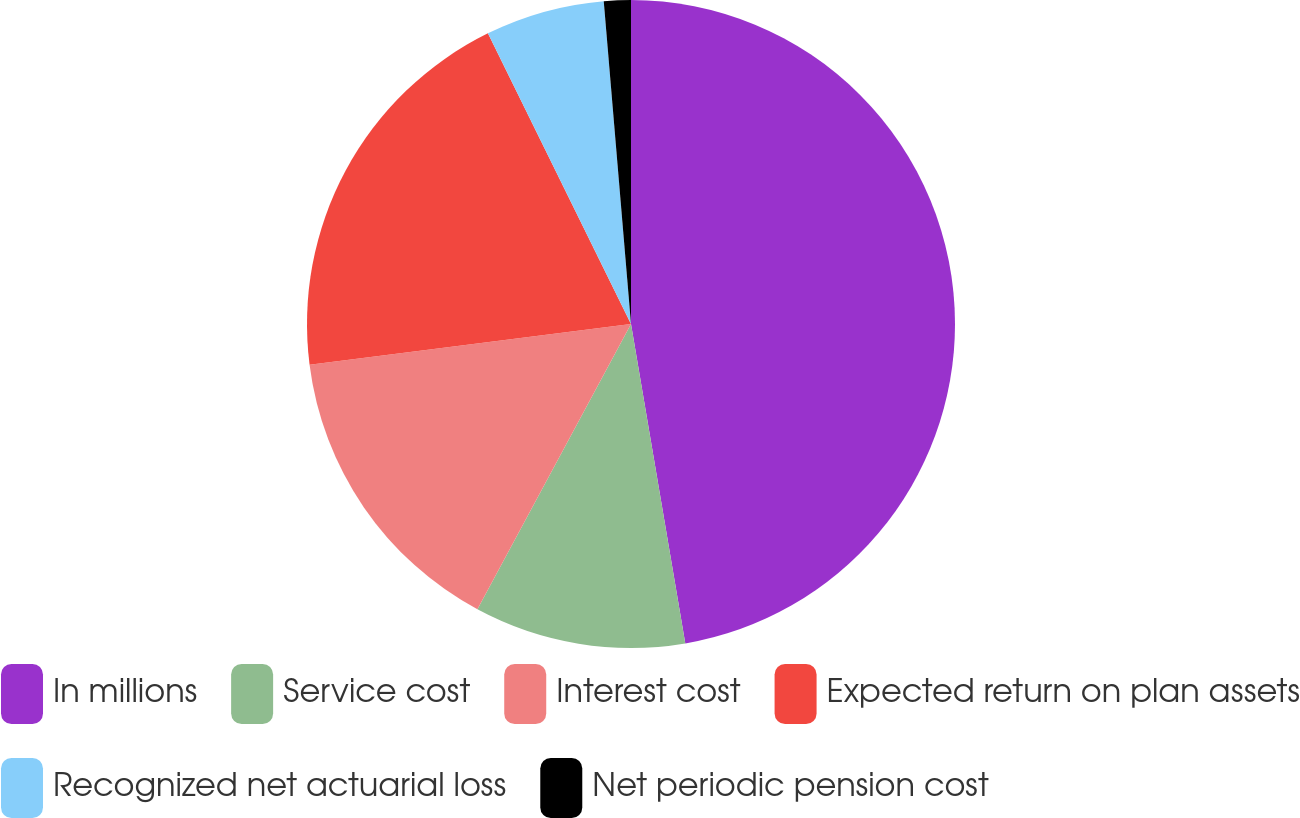<chart> <loc_0><loc_0><loc_500><loc_500><pie_chart><fcel>In millions<fcel>Service cost<fcel>Interest cost<fcel>Expected return on plan assets<fcel>Recognized net actuarial loss<fcel>Net periodic pension cost<nl><fcel>47.32%<fcel>10.54%<fcel>15.13%<fcel>19.73%<fcel>5.94%<fcel>1.34%<nl></chart> 